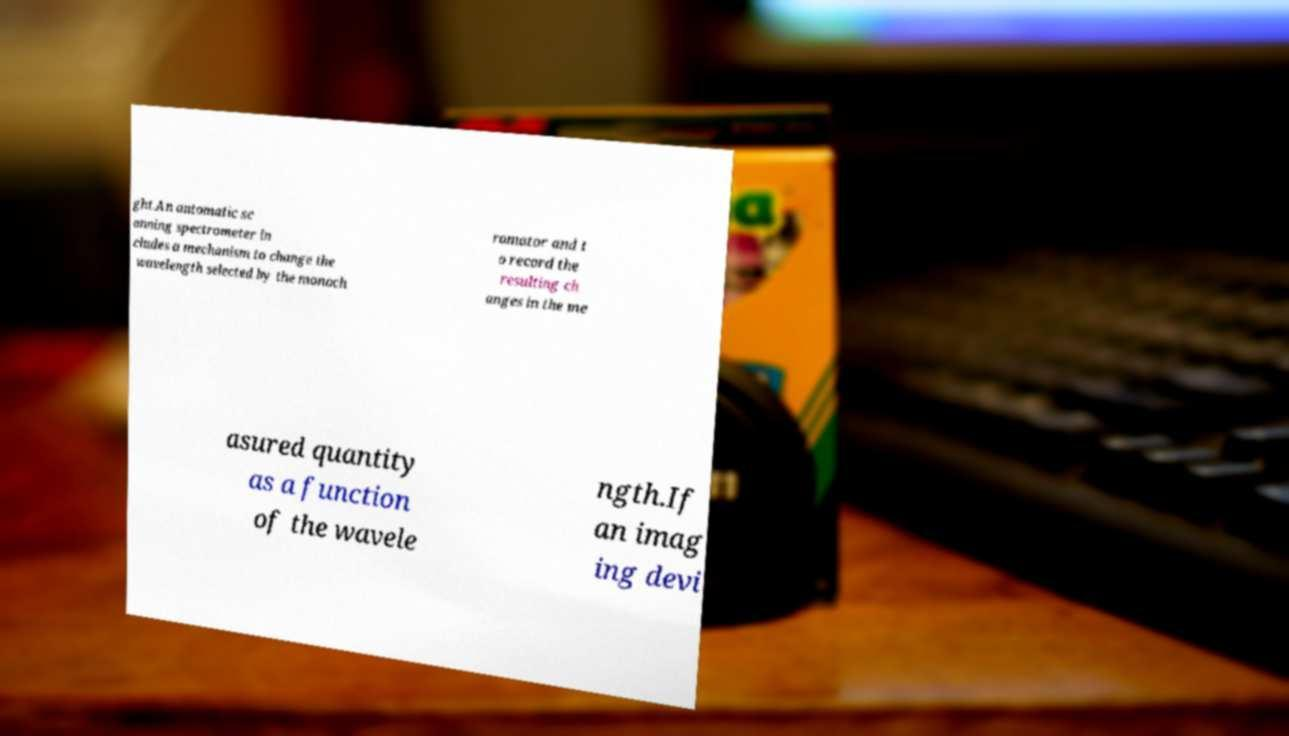Could you extract and type out the text from this image? ght.An automatic sc anning spectrometer in cludes a mechanism to change the wavelength selected by the monoch romator and t o record the resulting ch anges in the me asured quantity as a function of the wavele ngth.If an imag ing devi 